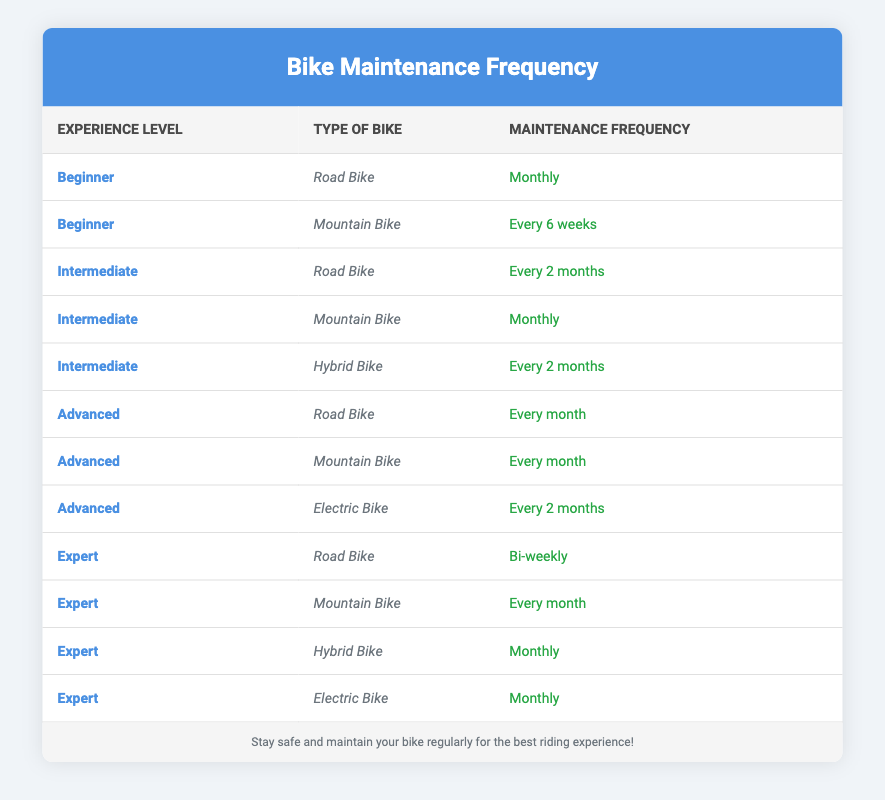What is the frequency of maintenance checks for beginner cyclists using a road bike? There is one entry in the table for beginner cyclists using a road bike, which states that the frequency of maintenance checks is "Monthly."
Answer: Monthly How often do intermediate cyclists check their mountain bikes? There is one entry for intermediate cyclists with a mountain bike, which shows that they conduct maintenance checks "Monthly."
Answer: Monthly Do advanced cyclists perform maintenance checks more frequently on road bikes compared to electric bikes? Advanced cyclists check their road bikes "Every month," while they check their electric bikes "Every 2 months." Since one is more frequent than the other, the answer is yes.
Answer: Yes What percentage of expert cyclists check their bikes bi-weekly? Out of the 4 entries for expert cyclists, only one (the road bike) checks bi-weekly. To find the percentage, we divide the count of those checking bi-weekly (1) by the total expert cyclists (4), then multiply by 100. (1/4)*100 = 25%.
Answer: 25% Are there any cyclists who check their mountain bikes every 6 weeks? Looking at the entries, there is only one frequency for mountain bikes among the beginners mentioned as "Every 6 weeks." Hence, the response is affirmative.
Answer: Yes What is the most common frequency for bike maintenance checks among expert cyclists? Checking the entries for expert cyclists, both mountain bikes and hybrids are checked "Monthly," while the road bike is bi-weekly, resulting in "Monthly" being the most mentioned frequency.
Answer: Monthly How many total different maintenance frequencies are listed for intermediate cyclists? For intermediate cyclists, there are three different types of bikes listed (road, mountain, hybrid) and their respective frequencies are "Every 2 months" and "Monthly." Thus there are two unique frequencies given the entries showcased.
Answer: 2 Do beginners check their bikes less frequently than advanced cyclists? Beginners have frequencies of "Monthly" for road bikes and "Every 6 weeks" for mountain bikes, while advanced cyclists check both road and mountain bikes "Every month" and electric bikes "Every 2 months." Advanced cyclists are not less frequent in this context.
Answer: No What is the maintenance frequency difference between electric bike checks for advanced and expert cyclists? Advanced cyclists check their electric bikes "Every 2 months," while expert cyclists check theirs "Monthly." The difference in frequency is thus 1 month in favor of the experts since every month is more frequent than every 2 months.
Answer: 1 month 